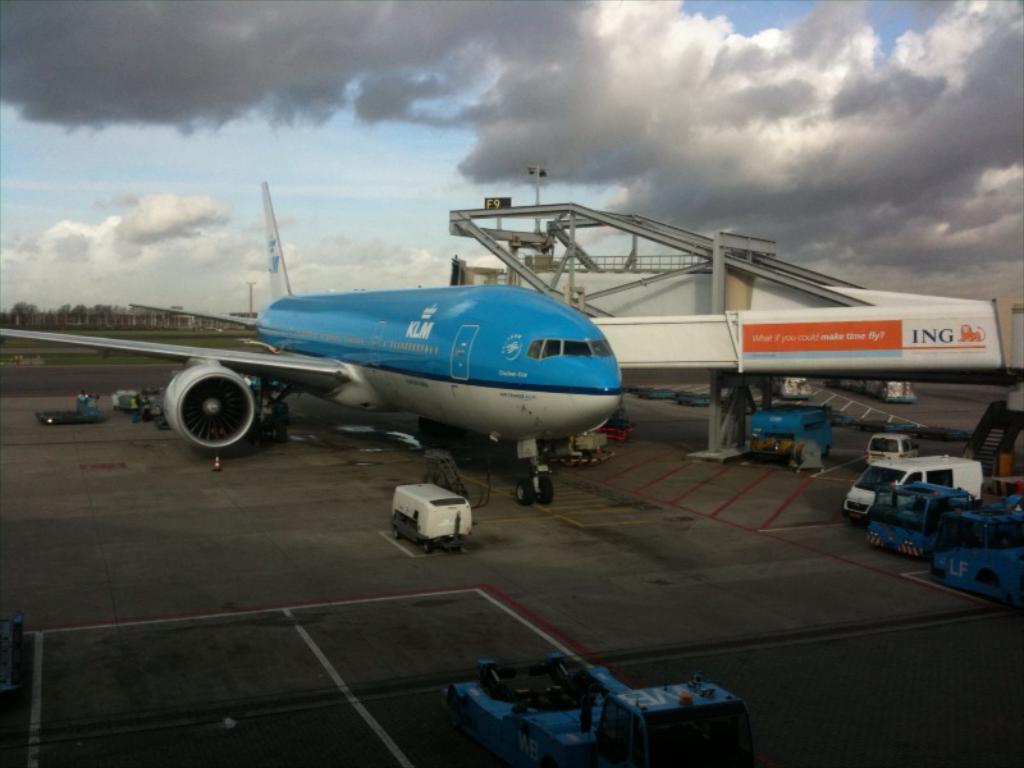Can you describe this image briefly? This picture is clicked outside. In the foreground we can see the vehicles seems to be parked on the ground. In the center there is an airplane parked on the ground. On the left we can see the persons like things and we can see the vehicles. On the right we can see the text and the depiction of an animal on the object and we can see the metal rods, stairway and many other objects. In the background we can see the sky with the clouds and we can see the trees, buildings and the green grass and some objects and we can see the text on the airplane. 